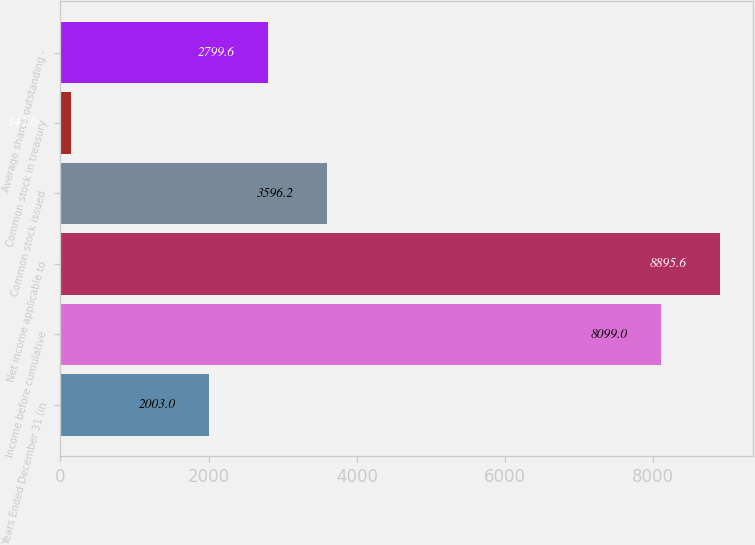Convert chart. <chart><loc_0><loc_0><loc_500><loc_500><bar_chart><fcel>Years Ended December 31 (in<fcel>Income before cumulative<fcel>Net income applicable to<fcel>Common stock issued<fcel>Common stock in treasury<fcel>Average shares outstanding -<nl><fcel>2003<fcel>8099<fcel>8895.6<fcel>3596.2<fcel>142<fcel>2799.6<nl></chart> 